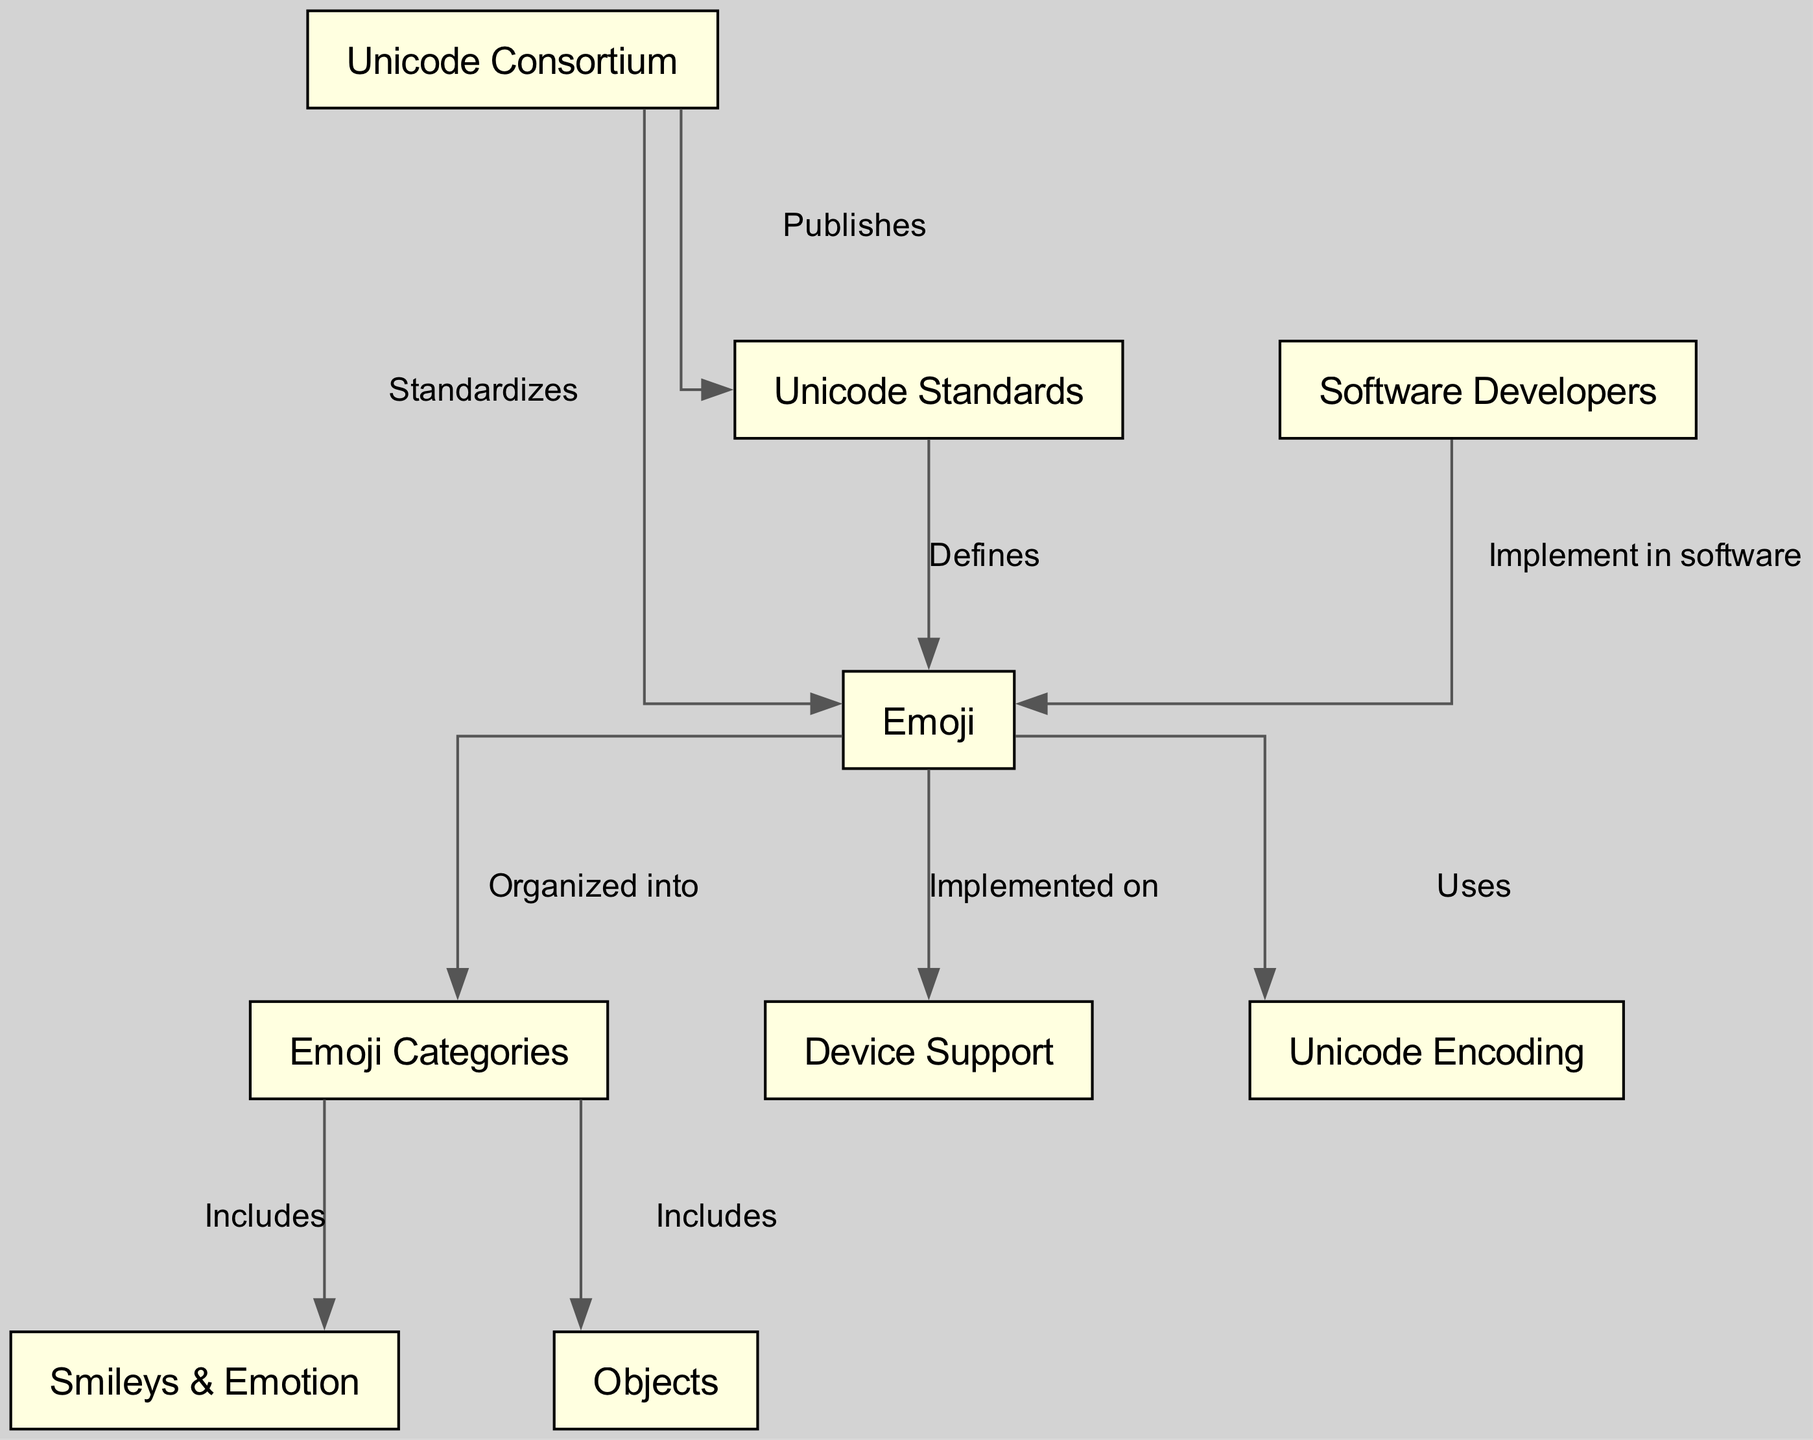What entity standardizes emojis? The diagram shows a direct edge from "Unicode Consortium" to "Emoji" labeled "Standardizes". This indicates that the Unicode Consortium is the entity responsible for establishing the standards for emojis.
Answer: Unicode Consortium How many emoji categories are mentioned? The diagram includes a node labeled "Emoji Categories", which has edges leading to "Smileys & Emotion" and "Objects". Since those two categories are included under "Emoji Categories", there are a total of 2 categories mentioned.
Answer: 2 What do emojis use for representation? The edge in the diagram from "Emoji" to "Unicode Encoding" labeled "Uses" indicates that emojis are represented using Unicode Encoding.
Answer: Unicode Encoding Which group of people implements emojis in software? The diagram connects "Software Developers" to "Emoji" with an edge labeled "Implement in software". Therefore, software developers are the ones who implement emojis in software.
Answer: Software Developers Which category includes smileys? The edge from "Emoji Categories" to "Smileys & Emotion" labeled "Includes" indicates that smileys are part of the emoji categories.
Answer: Smileys & Emotion What does the Unicode Consortium publish? According to the edge from "Unicode" to "Standard" labeled "Publishes", the Unicode Consortium publishes standards.
Answer: Standards What categories are organized under emojis? The diagram shows an edge from "Emoji" to "Categories" that states "Organized into". The two categories specifically mentioned are "Smileys & Emotion" and "Objects", therefore both of these categories are organized under emojis.
Answer: Smileys & Emotion, Objects What device support emojis? There is an edge leading from "Emoji" to "Device Support" labeled "Implemented on", indicating that emojis are supported on various devices. The specific devices are not listed, but it generally means all devices that comply with these standards.
Answer: Device Support How does Unicode affect emojis? The diagram indicates through a specific edge labeled "Defines" from "Standards" to "Emoji" that Unicode standards dictate the definitions and usage of emojis. Thus, the Unicode standards play a crucial role in shaping how emojis are defined and utilized.
Answer: Defines 